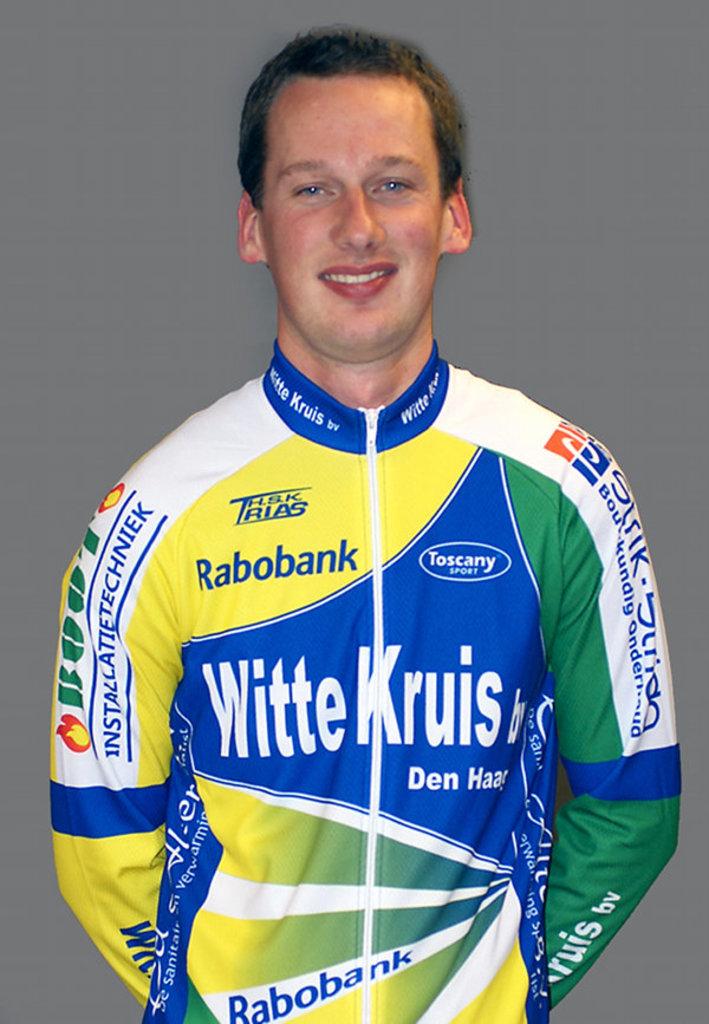What sports company is circled on this man's shirt?
Your answer should be very brief. Toscany. 